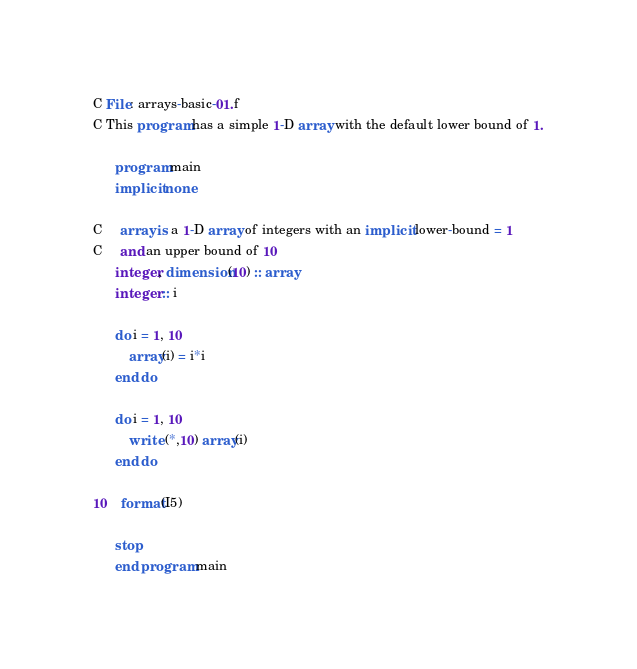<code> <loc_0><loc_0><loc_500><loc_500><_FORTRAN_>C File: arrays-basic-01.f
C This program has a simple 1-D array with the default lower bound of 1.

      program main
      implicit none

C     array is a 1-D array of integers with an implicit lower-bound = 1
C     and an upper bound of 10
      integer, dimension(10) :: array    
      integer :: i

      do i = 1, 10
          array(i) = i*i
      end do

      do i = 1, 10
          write (*,10) array(i)
      end do

10    format(I5)

      stop
      end program main
</code> 